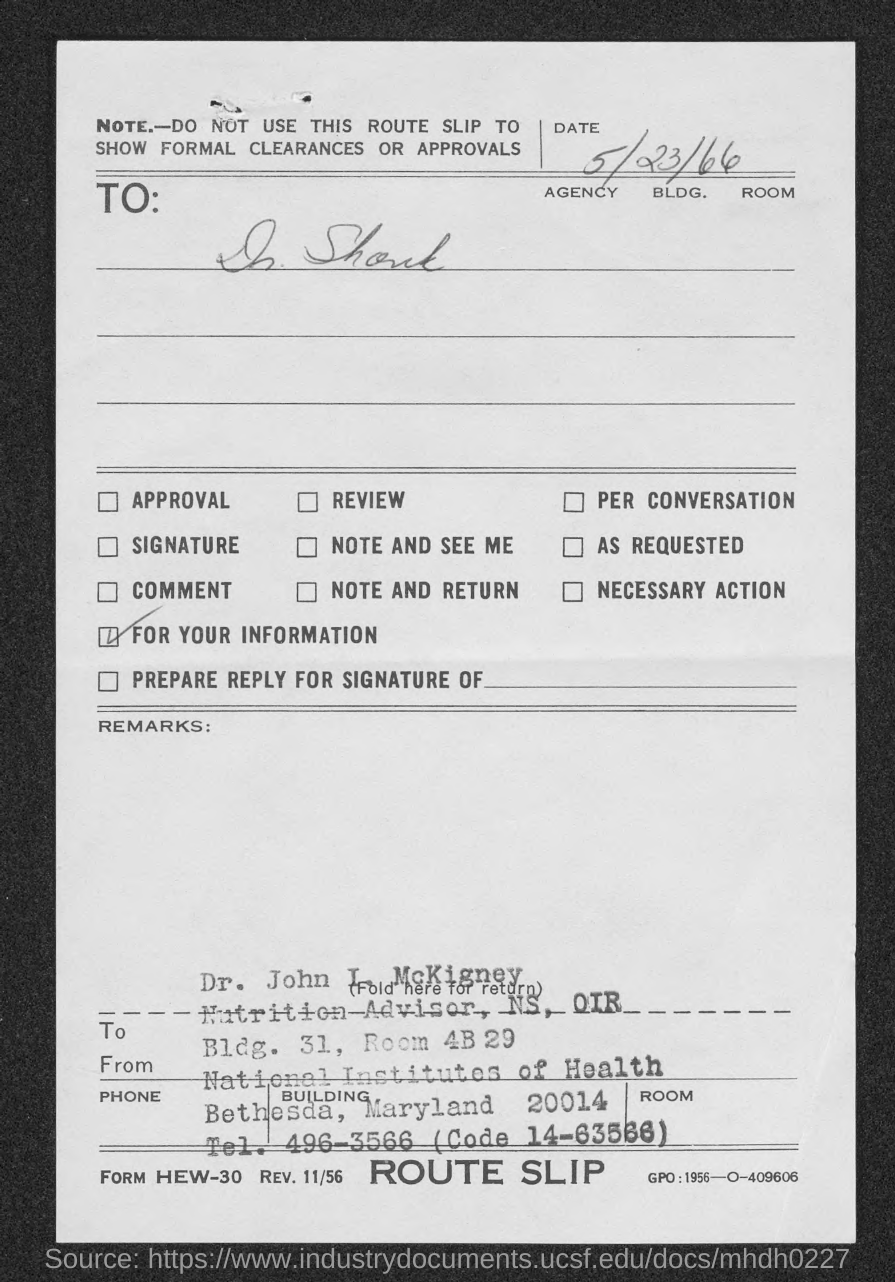Which is the date on the route slip?
Offer a terse response. 5/23/66. 